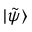<formula> <loc_0><loc_0><loc_500><loc_500>| \tilde { \psi } \rangle</formula> 